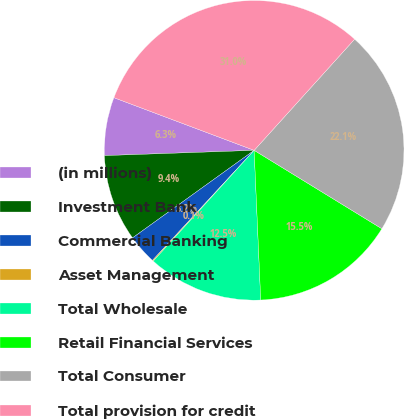Convert chart to OTSL. <chart><loc_0><loc_0><loc_500><loc_500><pie_chart><fcel>(in millions)<fcel>Investment Bank<fcel>Commercial Banking<fcel>Asset Management<fcel>Total Wholesale<fcel>Retail Financial Services<fcel>Total Consumer<fcel>Total provision for credit<nl><fcel>6.28%<fcel>9.37%<fcel>3.2%<fcel>0.11%<fcel>12.46%<fcel>15.54%<fcel>22.07%<fcel>30.98%<nl></chart> 